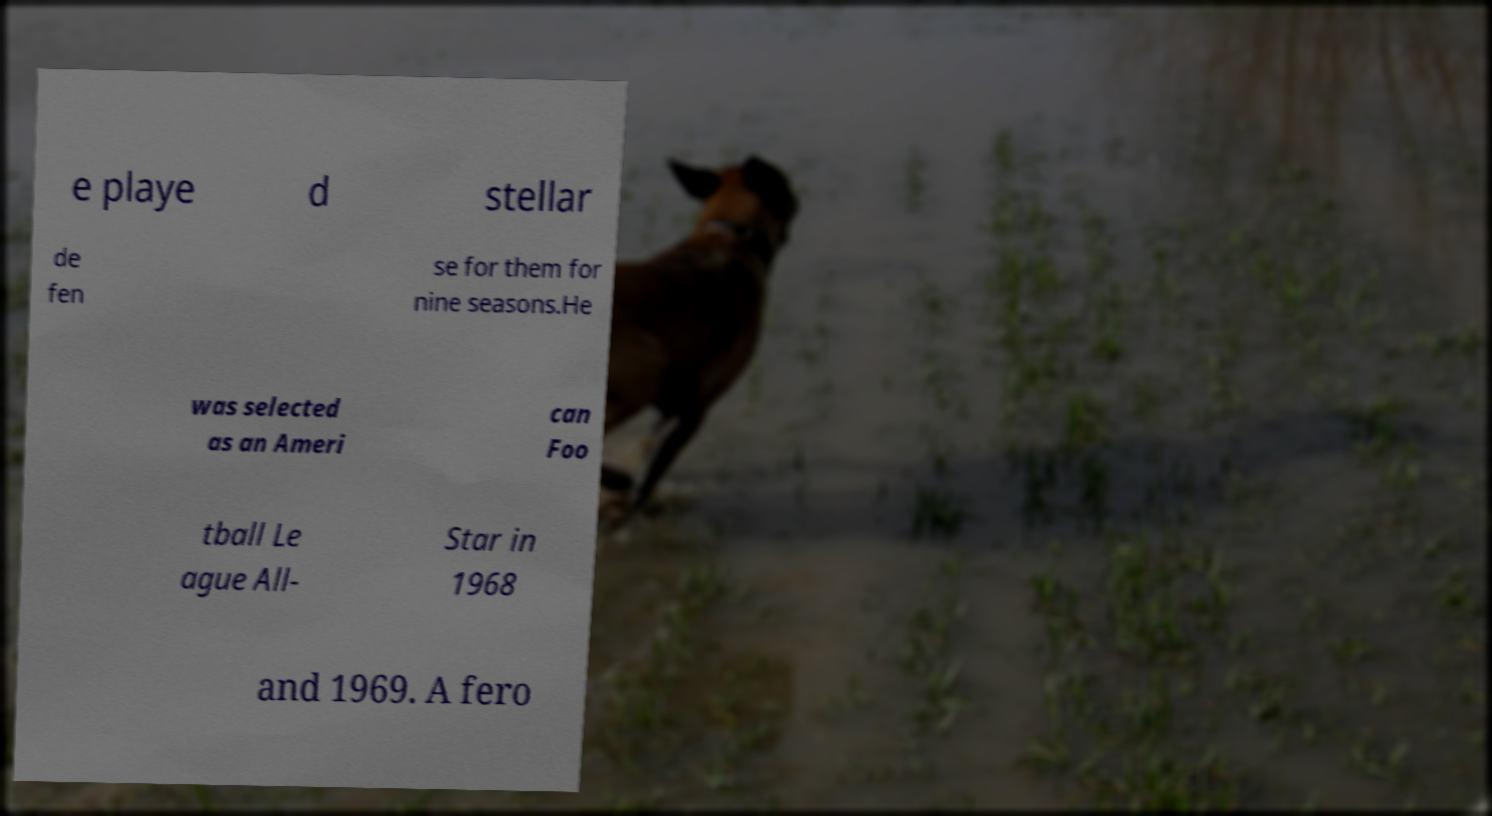Can you read and provide the text displayed in the image?This photo seems to have some interesting text. Can you extract and type it out for me? e playe d stellar de fen se for them for nine seasons.He was selected as an Ameri can Foo tball Le ague All- Star in 1968 and 1969. A fero 